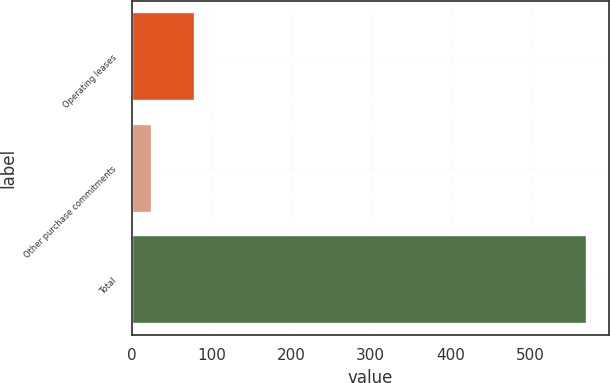Convert chart. <chart><loc_0><loc_0><loc_500><loc_500><bar_chart><fcel>Operating leases<fcel>Other purchase commitments<fcel>Total<nl><fcel>79.6<fcel>25<fcel>571<nl></chart> 